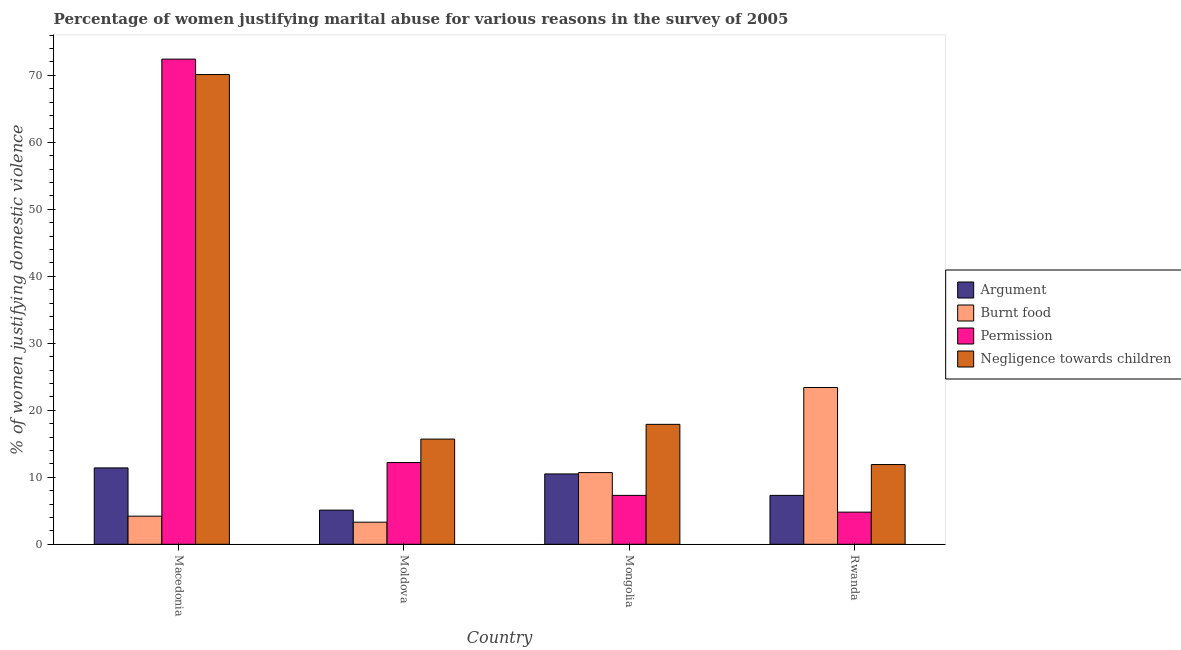How many different coloured bars are there?
Offer a very short reply. 4. How many groups of bars are there?
Make the answer very short. 4. Are the number of bars on each tick of the X-axis equal?
Keep it short and to the point. Yes. How many bars are there on the 1st tick from the left?
Ensure brevity in your answer.  4. How many bars are there on the 2nd tick from the right?
Your response must be concise. 4. What is the label of the 3rd group of bars from the left?
Your answer should be very brief. Mongolia. In how many cases, is the number of bars for a given country not equal to the number of legend labels?
Your answer should be very brief. 0. What is the percentage of women justifying abuse for going without permission in Macedonia?
Your answer should be very brief. 72.4. In which country was the percentage of women justifying abuse for burning food maximum?
Make the answer very short. Rwanda. In which country was the percentage of women justifying abuse for burning food minimum?
Your answer should be compact. Moldova. What is the total percentage of women justifying abuse for showing negligence towards children in the graph?
Make the answer very short. 115.6. What is the difference between the percentage of women justifying abuse for burning food in Macedonia and that in Moldova?
Ensure brevity in your answer.  0.9. What is the difference between the percentage of women justifying abuse for going without permission in Moldova and the percentage of women justifying abuse in the case of an argument in Mongolia?
Give a very brief answer. 1.7. What is the average percentage of women justifying abuse in the case of an argument per country?
Give a very brief answer. 8.57. What is the difference between the percentage of women justifying abuse for burning food and percentage of women justifying abuse in the case of an argument in Rwanda?
Ensure brevity in your answer.  16.1. What is the ratio of the percentage of women justifying abuse in the case of an argument in Macedonia to that in Rwanda?
Your response must be concise. 1.56. Is the difference between the percentage of women justifying abuse in the case of an argument in Moldova and Mongolia greater than the difference between the percentage of women justifying abuse for burning food in Moldova and Mongolia?
Give a very brief answer. Yes. What is the difference between the highest and the second highest percentage of women justifying abuse in the case of an argument?
Offer a terse response. 0.9. What is the difference between the highest and the lowest percentage of women justifying abuse for showing negligence towards children?
Offer a terse response. 58.2. What does the 2nd bar from the left in Mongolia represents?
Keep it short and to the point. Burnt food. What does the 1st bar from the right in Mongolia represents?
Keep it short and to the point. Negligence towards children. Is it the case that in every country, the sum of the percentage of women justifying abuse in the case of an argument and percentage of women justifying abuse for burning food is greater than the percentage of women justifying abuse for going without permission?
Ensure brevity in your answer.  No. How many countries are there in the graph?
Offer a terse response. 4. Are the values on the major ticks of Y-axis written in scientific E-notation?
Ensure brevity in your answer.  No. Where does the legend appear in the graph?
Offer a very short reply. Center right. How many legend labels are there?
Provide a succinct answer. 4. How are the legend labels stacked?
Make the answer very short. Vertical. What is the title of the graph?
Your response must be concise. Percentage of women justifying marital abuse for various reasons in the survey of 2005. Does "Germany" appear as one of the legend labels in the graph?
Give a very brief answer. No. What is the label or title of the Y-axis?
Make the answer very short. % of women justifying domestic violence. What is the % of women justifying domestic violence of Burnt food in Macedonia?
Provide a short and direct response. 4.2. What is the % of women justifying domestic violence in Permission in Macedonia?
Make the answer very short. 72.4. What is the % of women justifying domestic violence in Negligence towards children in Macedonia?
Your answer should be very brief. 70.1. What is the % of women justifying domestic violence of Burnt food in Moldova?
Offer a terse response. 3.3. What is the % of women justifying domestic violence in Permission in Moldova?
Offer a terse response. 12.2. What is the % of women justifying domestic violence in Permission in Mongolia?
Make the answer very short. 7.3. What is the % of women justifying domestic violence of Negligence towards children in Mongolia?
Your response must be concise. 17.9. What is the % of women justifying domestic violence in Burnt food in Rwanda?
Provide a succinct answer. 23.4. What is the % of women justifying domestic violence in Permission in Rwanda?
Ensure brevity in your answer.  4.8. What is the % of women justifying domestic violence of Negligence towards children in Rwanda?
Your response must be concise. 11.9. Across all countries, what is the maximum % of women justifying domestic violence of Argument?
Offer a very short reply. 11.4. Across all countries, what is the maximum % of women justifying domestic violence of Burnt food?
Give a very brief answer. 23.4. Across all countries, what is the maximum % of women justifying domestic violence of Permission?
Make the answer very short. 72.4. Across all countries, what is the maximum % of women justifying domestic violence of Negligence towards children?
Offer a terse response. 70.1. Across all countries, what is the minimum % of women justifying domestic violence of Argument?
Make the answer very short. 5.1. Across all countries, what is the minimum % of women justifying domestic violence of Burnt food?
Give a very brief answer. 3.3. Across all countries, what is the minimum % of women justifying domestic violence of Permission?
Give a very brief answer. 4.8. Across all countries, what is the minimum % of women justifying domestic violence in Negligence towards children?
Provide a short and direct response. 11.9. What is the total % of women justifying domestic violence of Argument in the graph?
Ensure brevity in your answer.  34.3. What is the total % of women justifying domestic violence in Burnt food in the graph?
Provide a succinct answer. 41.6. What is the total % of women justifying domestic violence in Permission in the graph?
Ensure brevity in your answer.  96.7. What is the total % of women justifying domestic violence of Negligence towards children in the graph?
Provide a short and direct response. 115.6. What is the difference between the % of women justifying domestic violence of Burnt food in Macedonia and that in Moldova?
Provide a short and direct response. 0.9. What is the difference between the % of women justifying domestic violence in Permission in Macedonia and that in Moldova?
Your answer should be compact. 60.2. What is the difference between the % of women justifying domestic violence in Negligence towards children in Macedonia and that in Moldova?
Make the answer very short. 54.4. What is the difference between the % of women justifying domestic violence of Argument in Macedonia and that in Mongolia?
Keep it short and to the point. 0.9. What is the difference between the % of women justifying domestic violence in Permission in Macedonia and that in Mongolia?
Offer a terse response. 65.1. What is the difference between the % of women justifying domestic violence in Negligence towards children in Macedonia and that in Mongolia?
Your answer should be compact. 52.2. What is the difference between the % of women justifying domestic violence of Argument in Macedonia and that in Rwanda?
Offer a very short reply. 4.1. What is the difference between the % of women justifying domestic violence of Burnt food in Macedonia and that in Rwanda?
Keep it short and to the point. -19.2. What is the difference between the % of women justifying domestic violence in Permission in Macedonia and that in Rwanda?
Provide a short and direct response. 67.6. What is the difference between the % of women justifying domestic violence of Negligence towards children in Macedonia and that in Rwanda?
Offer a terse response. 58.2. What is the difference between the % of women justifying domestic violence of Argument in Moldova and that in Mongolia?
Your answer should be very brief. -5.4. What is the difference between the % of women justifying domestic violence of Burnt food in Moldova and that in Mongolia?
Make the answer very short. -7.4. What is the difference between the % of women justifying domestic violence in Permission in Moldova and that in Mongolia?
Keep it short and to the point. 4.9. What is the difference between the % of women justifying domestic violence of Burnt food in Moldova and that in Rwanda?
Ensure brevity in your answer.  -20.1. What is the difference between the % of women justifying domestic violence of Argument in Mongolia and that in Rwanda?
Your answer should be compact. 3.2. What is the difference between the % of women justifying domestic violence in Permission in Mongolia and that in Rwanda?
Your answer should be compact. 2.5. What is the difference between the % of women justifying domestic violence in Negligence towards children in Mongolia and that in Rwanda?
Your response must be concise. 6. What is the difference between the % of women justifying domestic violence of Argument in Macedonia and the % of women justifying domestic violence of Burnt food in Moldova?
Provide a succinct answer. 8.1. What is the difference between the % of women justifying domestic violence of Argument in Macedonia and the % of women justifying domestic violence of Permission in Moldova?
Offer a very short reply. -0.8. What is the difference between the % of women justifying domestic violence in Burnt food in Macedonia and the % of women justifying domestic violence in Permission in Moldova?
Your answer should be compact. -8. What is the difference between the % of women justifying domestic violence of Permission in Macedonia and the % of women justifying domestic violence of Negligence towards children in Moldova?
Keep it short and to the point. 56.7. What is the difference between the % of women justifying domestic violence of Argument in Macedonia and the % of women justifying domestic violence of Permission in Mongolia?
Offer a very short reply. 4.1. What is the difference between the % of women justifying domestic violence of Burnt food in Macedonia and the % of women justifying domestic violence of Negligence towards children in Mongolia?
Keep it short and to the point. -13.7. What is the difference between the % of women justifying domestic violence of Permission in Macedonia and the % of women justifying domestic violence of Negligence towards children in Mongolia?
Provide a short and direct response. 54.5. What is the difference between the % of women justifying domestic violence of Argument in Macedonia and the % of women justifying domestic violence of Burnt food in Rwanda?
Provide a short and direct response. -12. What is the difference between the % of women justifying domestic violence of Argument in Macedonia and the % of women justifying domestic violence of Permission in Rwanda?
Provide a succinct answer. 6.6. What is the difference between the % of women justifying domestic violence of Argument in Macedonia and the % of women justifying domestic violence of Negligence towards children in Rwanda?
Make the answer very short. -0.5. What is the difference between the % of women justifying domestic violence in Burnt food in Macedonia and the % of women justifying domestic violence in Permission in Rwanda?
Your answer should be compact. -0.6. What is the difference between the % of women justifying domestic violence of Burnt food in Macedonia and the % of women justifying domestic violence of Negligence towards children in Rwanda?
Your answer should be very brief. -7.7. What is the difference between the % of women justifying domestic violence in Permission in Macedonia and the % of women justifying domestic violence in Negligence towards children in Rwanda?
Offer a terse response. 60.5. What is the difference between the % of women justifying domestic violence of Burnt food in Moldova and the % of women justifying domestic violence of Negligence towards children in Mongolia?
Make the answer very short. -14.6. What is the difference between the % of women justifying domestic violence in Permission in Moldova and the % of women justifying domestic violence in Negligence towards children in Mongolia?
Ensure brevity in your answer.  -5.7. What is the difference between the % of women justifying domestic violence of Argument in Moldova and the % of women justifying domestic violence of Burnt food in Rwanda?
Your answer should be very brief. -18.3. What is the difference between the % of women justifying domestic violence of Argument in Moldova and the % of women justifying domestic violence of Permission in Rwanda?
Ensure brevity in your answer.  0.3. What is the difference between the % of women justifying domestic violence in Argument in Moldova and the % of women justifying domestic violence in Negligence towards children in Rwanda?
Make the answer very short. -6.8. What is the difference between the % of women justifying domestic violence in Burnt food in Moldova and the % of women justifying domestic violence in Permission in Rwanda?
Your response must be concise. -1.5. What is the difference between the % of women justifying domestic violence in Burnt food in Moldova and the % of women justifying domestic violence in Negligence towards children in Rwanda?
Give a very brief answer. -8.6. What is the difference between the % of women justifying domestic violence of Permission in Moldova and the % of women justifying domestic violence of Negligence towards children in Rwanda?
Offer a terse response. 0.3. What is the difference between the % of women justifying domestic violence of Burnt food in Mongolia and the % of women justifying domestic violence of Permission in Rwanda?
Make the answer very short. 5.9. What is the difference between the % of women justifying domestic violence of Permission in Mongolia and the % of women justifying domestic violence of Negligence towards children in Rwanda?
Ensure brevity in your answer.  -4.6. What is the average % of women justifying domestic violence in Argument per country?
Your answer should be compact. 8.57. What is the average % of women justifying domestic violence in Permission per country?
Your answer should be compact. 24.18. What is the average % of women justifying domestic violence in Negligence towards children per country?
Offer a very short reply. 28.9. What is the difference between the % of women justifying domestic violence of Argument and % of women justifying domestic violence of Burnt food in Macedonia?
Your response must be concise. 7.2. What is the difference between the % of women justifying domestic violence in Argument and % of women justifying domestic violence in Permission in Macedonia?
Give a very brief answer. -61. What is the difference between the % of women justifying domestic violence of Argument and % of women justifying domestic violence of Negligence towards children in Macedonia?
Keep it short and to the point. -58.7. What is the difference between the % of women justifying domestic violence in Burnt food and % of women justifying domestic violence in Permission in Macedonia?
Offer a terse response. -68.2. What is the difference between the % of women justifying domestic violence in Burnt food and % of women justifying domestic violence in Negligence towards children in Macedonia?
Give a very brief answer. -65.9. What is the difference between the % of women justifying domestic violence of Argument and % of women justifying domestic violence of Permission in Moldova?
Keep it short and to the point. -7.1. What is the difference between the % of women justifying domestic violence of Burnt food and % of women justifying domestic violence of Negligence towards children in Moldova?
Your answer should be very brief. -12.4. What is the difference between the % of women justifying domestic violence of Permission and % of women justifying domestic violence of Negligence towards children in Moldova?
Give a very brief answer. -3.5. What is the difference between the % of women justifying domestic violence in Burnt food and % of women justifying domestic violence in Permission in Mongolia?
Give a very brief answer. 3.4. What is the difference between the % of women justifying domestic violence of Burnt food and % of women justifying domestic violence of Negligence towards children in Mongolia?
Offer a very short reply. -7.2. What is the difference between the % of women justifying domestic violence in Argument and % of women justifying domestic violence in Burnt food in Rwanda?
Your response must be concise. -16.1. What is the difference between the % of women justifying domestic violence in Argument and % of women justifying domestic violence in Negligence towards children in Rwanda?
Offer a terse response. -4.6. What is the difference between the % of women justifying domestic violence in Burnt food and % of women justifying domestic violence in Permission in Rwanda?
Ensure brevity in your answer.  18.6. What is the ratio of the % of women justifying domestic violence of Argument in Macedonia to that in Moldova?
Provide a short and direct response. 2.24. What is the ratio of the % of women justifying domestic violence in Burnt food in Macedonia to that in Moldova?
Provide a short and direct response. 1.27. What is the ratio of the % of women justifying domestic violence in Permission in Macedonia to that in Moldova?
Your response must be concise. 5.93. What is the ratio of the % of women justifying domestic violence in Negligence towards children in Macedonia to that in Moldova?
Your answer should be compact. 4.46. What is the ratio of the % of women justifying domestic violence in Argument in Macedonia to that in Mongolia?
Provide a short and direct response. 1.09. What is the ratio of the % of women justifying domestic violence in Burnt food in Macedonia to that in Mongolia?
Make the answer very short. 0.39. What is the ratio of the % of women justifying domestic violence in Permission in Macedonia to that in Mongolia?
Provide a short and direct response. 9.92. What is the ratio of the % of women justifying domestic violence in Negligence towards children in Macedonia to that in Mongolia?
Offer a terse response. 3.92. What is the ratio of the % of women justifying domestic violence of Argument in Macedonia to that in Rwanda?
Your response must be concise. 1.56. What is the ratio of the % of women justifying domestic violence of Burnt food in Macedonia to that in Rwanda?
Keep it short and to the point. 0.18. What is the ratio of the % of women justifying domestic violence in Permission in Macedonia to that in Rwanda?
Provide a succinct answer. 15.08. What is the ratio of the % of women justifying domestic violence in Negligence towards children in Macedonia to that in Rwanda?
Keep it short and to the point. 5.89. What is the ratio of the % of women justifying domestic violence in Argument in Moldova to that in Mongolia?
Your answer should be compact. 0.49. What is the ratio of the % of women justifying domestic violence of Burnt food in Moldova to that in Mongolia?
Your response must be concise. 0.31. What is the ratio of the % of women justifying domestic violence in Permission in Moldova to that in Mongolia?
Your response must be concise. 1.67. What is the ratio of the % of women justifying domestic violence in Negligence towards children in Moldova to that in Mongolia?
Ensure brevity in your answer.  0.88. What is the ratio of the % of women justifying domestic violence in Argument in Moldova to that in Rwanda?
Make the answer very short. 0.7. What is the ratio of the % of women justifying domestic violence in Burnt food in Moldova to that in Rwanda?
Your answer should be very brief. 0.14. What is the ratio of the % of women justifying domestic violence of Permission in Moldova to that in Rwanda?
Provide a short and direct response. 2.54. What is the ratio of the % of women justifying domestic violence of Negligence towards children in Moldova to that in Rwanda?
Make the answer very short. 1.32. What is the ratio of the % of women justifying domestic violence of Argument in Mongolia to that in Rwanda?
Ensure brevity in your answer.  1.44. What is the ratio of the % of women justifying domestic violence of Burnt food in Mongolia to that in Rwanda?
Keep it short and to the point. 0.46. What is the ratio of the % of women justifying domestic violence of Permission in Mongolia to that in Rwanda?
Make the answer very short. 1.52. What is the ratio of the % of women justifying domestic violence in Negligence towards children in Mongolia to that in Rwanda?
Provide a short and direct response. 1.5. What is the difference between the highest and the second highest % of women justifying domestic violence in Burnt food?
Ensure brevity in your answer.  12.7. What is the difference between the highest and the second highest % of women justifying domestic violence of Permission?
Provide a succinct answer. 60.2. What is the difference between the highest and the second highest % of women justifying domestic violence in Negligence towards children?
Offer a terse response. 52.2. What is the difference between the highest and the lowest % of women justifying domestic violence in Burnt food?
Ensure brevity in your answer.  20.1. What is the difference between the highest and the lowest % of women justifying domestic violence of Permission?
Your answer should be very brief. 67.6. What is the difference between the highest and the lowest % of women justifying domestic violence in Negligence towards children?
Your answer should be very brief. 58.2. 